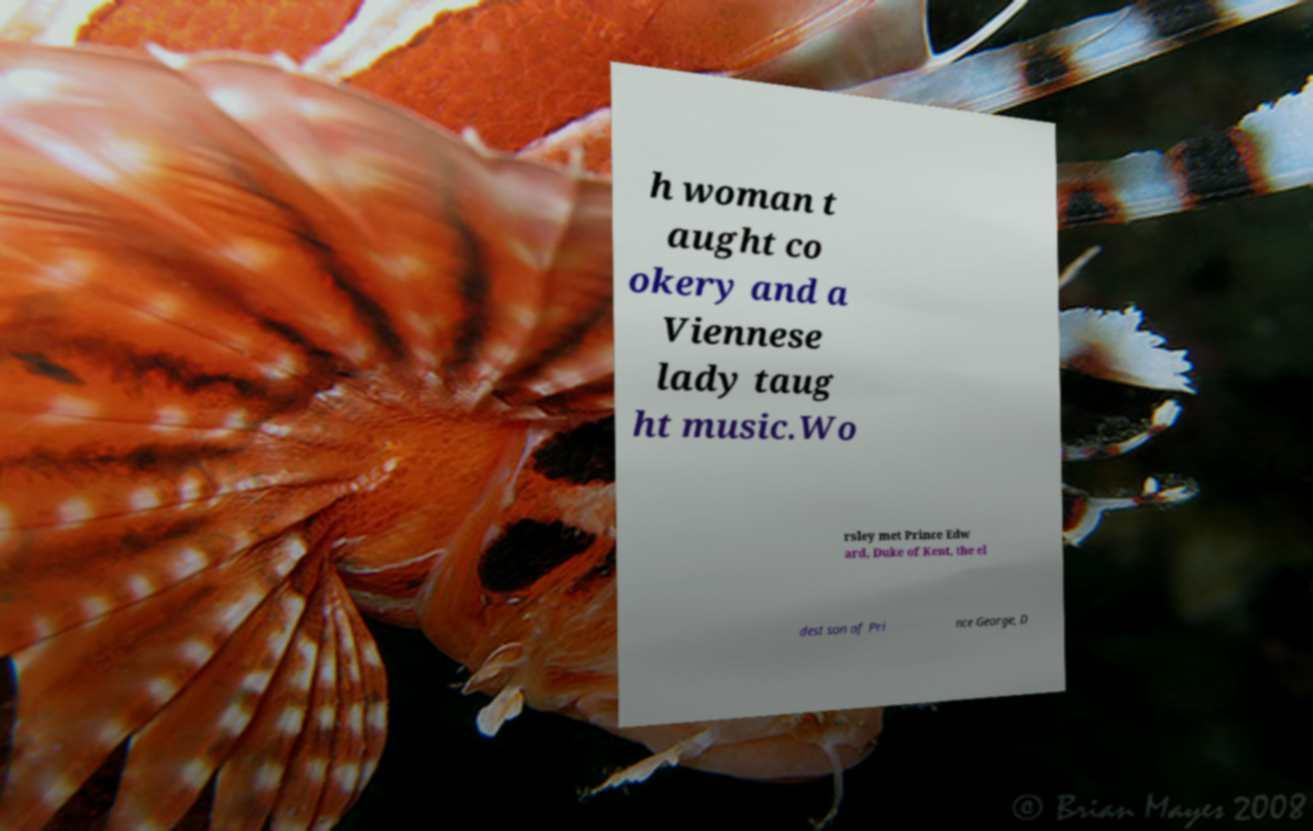Please identify and transcribe the text found in this image. h woman t aught co okery and a Viennese lady taug ht music.Wo rsley met Prince Edw ard, Duke of Kent, the el dest son of Pri nce George, D 